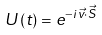<formula> <loc_0><loc_0><loc_500><loc_500>U \left ( t \right ) & = e ^ { - i \vec { v } \cdot \vec { S } }</formula> 